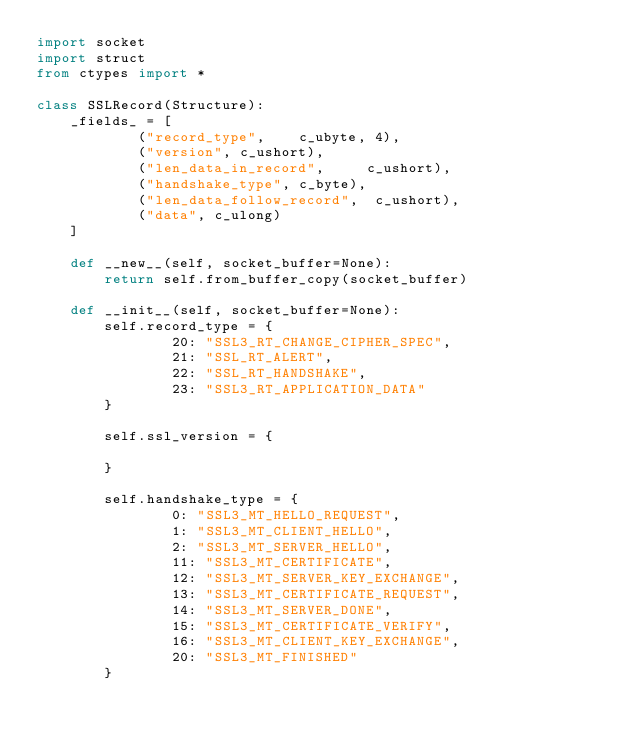Convert code to text. <code><loc_0><loc_0><loc_500><loc_500><_Python_>import socket
import struct
from ctypes import *

class SSLRecord(Structure):
    _fields_ = [
            ("record_type",    c_ubyte, 4),
            ("version", c_ushort),
            ("len_data_in_record",     c_ushort),
            ("handshake_type", c_byte),
            ("len_data_follow_record",  c_ushort),
            ("data", c_ulong)
    ]

    def __new__(self, socket_buffer=None):
        return self.from_buffer_copy(socket_buffer)

    def __init__(self, socket_buffer=None):
        self.record_type = {
                20: "SSL3_RT_CHANGE_CIPHER_SPEC",
                21: "SSL_RT_ALERT",
                22: "SSL_RT_HANDSHAKE",
                23: "SSL3_RT_APPLICATION_DATA"
        }

        self.ssl_version = {

        }

        self.handshake_type = {
                0: "SSL3_MT_HELLO_REQUEST",
                1: "SSL3_MT_CLIENT_HELLO",
                2: "SSL3_MT_SERVER_HELLO",
                11: "SSL3_MT_CERTIFICATE",
                12: "SSL3_MT_SERVER_KEY_EXCHANGE",
                13: "SSL3_MT_CERTIFICATE_REQUEST",
                14: "SSL3_MT_SERVER_DONE",
                15: "SSL3_MT_CERTIFICATE_VERIFY",
                16: "SSL3_MT_CLIENT_KEY_EXCHANGE",
                20: "SSL3_MT_FINISHED"
        }


</code> 